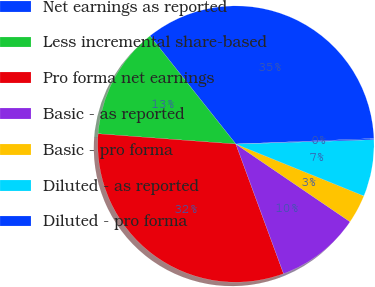<chart> <loc_0><loc_0><loc_500><loc_500><pie_chart><fcel>Net earnings as reported<fcel>Less incremental share-based<fcel>Pro forma net earnings<fcel>Basic - as reported<fcel>Basic - pro forma<fcel>Diluted - as reported<fcel>Diluted - pro forma<nl><fcel>35.04%<fcel>13.13%<fcel>31.79%<fcel>9.88%<fcel>3.38%<fcel>6.63%<fcel>0.13%<nl></chart> 